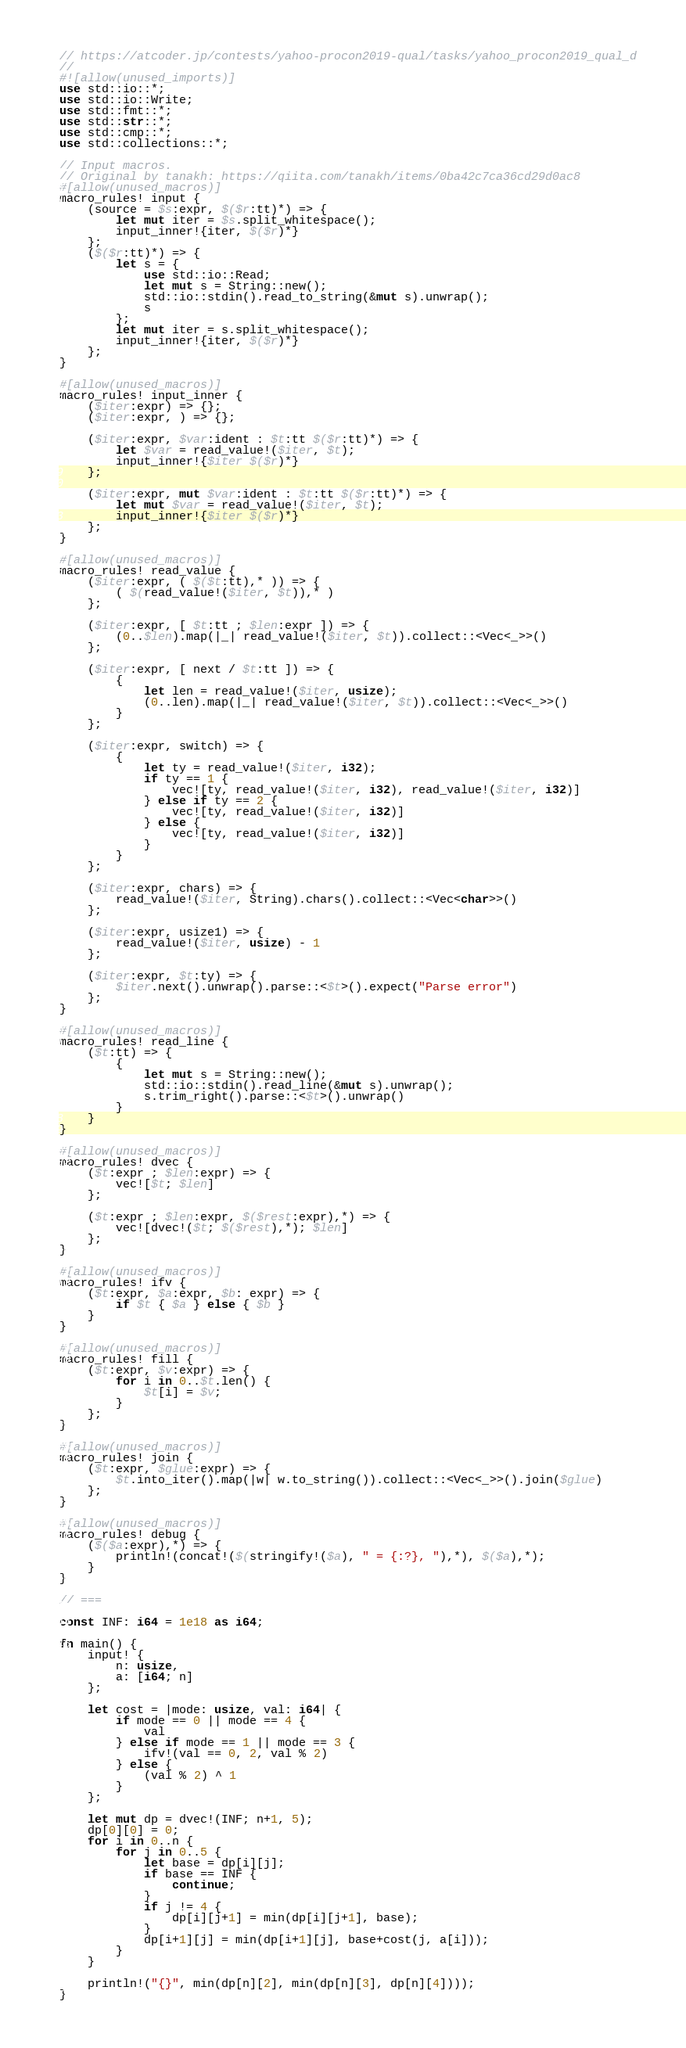<code> <loc_0><loc_0><loc_500><loc_500><_Rust_>// https://atcoder.jp/contests/yahoo-procon2019-qual/tasks/yahoo_procon2019_qual_d
//
#![allow(unused_imports)]
use std::io::*;
use std::io::Write;
use std::fmt::*;
use std::str::*;
use std::cmp::*;
use std::collections::*;

// Input macros.
// Original by tanakh: https://qiita.com/tanakh/items/0ba42c7ca36cd29d0ac8
#[allow(unused_macros)]
macro_rules! input {
    (source = $s:expr, $($r:tt)*) => {
        let mut iter = $s.split_whitespace();
        input_inner!{iter, $($r)*}
    };
    ($($r:tt)*) => {
        let s = {
            use std::io::Read;
            let mut s = String::new();
            std::io::stdin().read_to_string(&mut s).unwrap();
            s
        };
        let mut iter = s.split_whitespace();
        input_inner!{iter, $($r)*}
    };
}

#[allow(unused_macros)]
macro_rules! input_inner {
    ($iter:expr) => {};
    ($iter:expr, ) => {};

    ($iter:expr, $var:ident : $t:tt $($r:tt)*) => {
        let $var = read_value!($iter, $t);
        input_inner!{$iter $($r)*}
    };

    ($iter:expr, mut $var:ident : $t:tt $($r:tt)*) => {
        let mut $var = read_value!($iter, $t);
        input_inner!{$iter $($r)*}
    };
}

#[allow(unused_macros)]
macro_rules! read_value {
    ($iter:expr, ( $($t:tt),* )) => {
        ( $(read_value!($iter, $t)),* )
    };

    ($iter:expr, [ $t:tt ; $len:expr ]) => {
        (0..$len).map(|_| read_value!($iter, $t)).collect::<Vec<_>>()
    };

    ($iter:expr, [ next / $t:tt ]) => {
        {
            let len = read_value!($iter, usize);
            (0..len).map(|_| read_value!($iter, $t)).collect::<Vec<_>>()
        }
    };

    ($iter:expr, switch) => {
        {
            let ty = read_value!($iter, i32);
            if ty == 1 {
                vec![ty, read_value!($iter, i32), read_value!($iter, i32)]
            } else if ty == 2 {
                vec![ty, read_value!($iter, i32)]
            } else {
                vec![ty, read_value!($iter, i32)]
            }
        }
    };

    ($iter:expr, chars) => {
        read_value!($iter, String).chars().collect::<Vec<char>>()
    };

    ($iter:expr, usize1) => {
        read_value!($iter, usize) - 1
    };

    ($iter:expr, $t:ty) => {
        $iter.next().unwrap().parse::<$t>().expect("Parse error")
    };
}

#[allow(unused_macros)]
macro_rules! read_line {
    ($t:tt) => {
        {
            let mut s = String::new();
            std::io::stdin().read_line(&mut s).unwrap();
            s.trim_right().parse::<$t>().unwrap()
        }
    }
}

#[allow(unused_macros)]
macro_rules! dvec {
    ($t:expr ; $len:expr) => {
        vec![$t; $len]
    };

    ($t:expr ; $len:expr, $($rest:expr),*) => {
        vec![dvec!($t; $($rest),*); $len]
    };
}

#[allow(unused_macros)]
macro_rules! ifv {
    ($t:expr, $a:expr, $b: expr) => {
        if $t { $a } else { $b }
    }
}

#[allow(unused_macros)]
macro_rules! fill {
    ($t:expr, $v:expr) => {
        for i in 0..$t.len() {
            $t[i] = $v;
        }
    };
}

#[allow(unused_macros)]
macro_rules! join {
    ($t:expr, $glue:expr) => {
        $t.into_iter().map(|w| w.to_string()).collect::<Vec<_>>().join($glue)
    };
}

#[allow(unused_macros)]
macro_rules! debug {
    ($($a:expr),*) => {
        println!(concat!($(stringify!($a), " = {:?}, "),*), $($a),*);
    }
}

// ===

const INF: i64 = 1e18 as i64;

fn main() {
    input! {
        n: usize,
        a: [i64; n]
    };

    let cost = |mode: usize, val: i64| {
        if mode == 0 || mode == 4 {
            val
        } else if mode == 1 || mode == 3 {
            ifv!(val == 0, 2, val % 2)
        } else {
            (val % 2) ^ 1
        }
    };

    let mut dp = dvec!(INF; n+1, 5);
    dp[0][0] = 0;
    for i in 0..n {
        for j in 0..5 {
            let base = dp[i][j];
            if base == INF {
                continue;
            }
            if j != 4 {
                dp[i][j+1] = min(dp[i][j+1], base);
            }
            dp[i+1][j] = min(dp[i+1][j], base+cost(j, a[i]));
        }
    }

    println!("{}", min(dp[n][2], min(dp[n][3], dp[n][4])));
}
</code> 